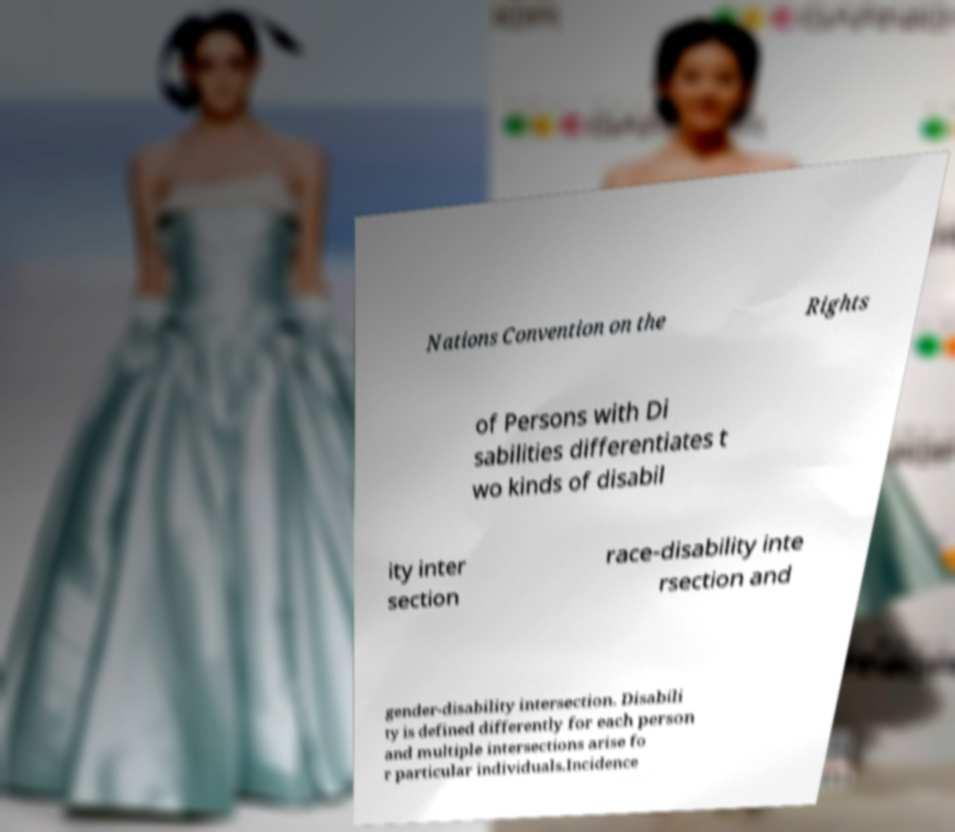There's text embedded in this image that I need extracted. Can you transcribe it verbatim? Nations Convention on the Rights of Persons with Di sabilities differentiates t wo kinds of disabil ity inter section race-disability inte rsection and gender-disability intersection. Disabili ty is defined differently for each person and multiple intersections arise fo r particular individuals.Incidence 